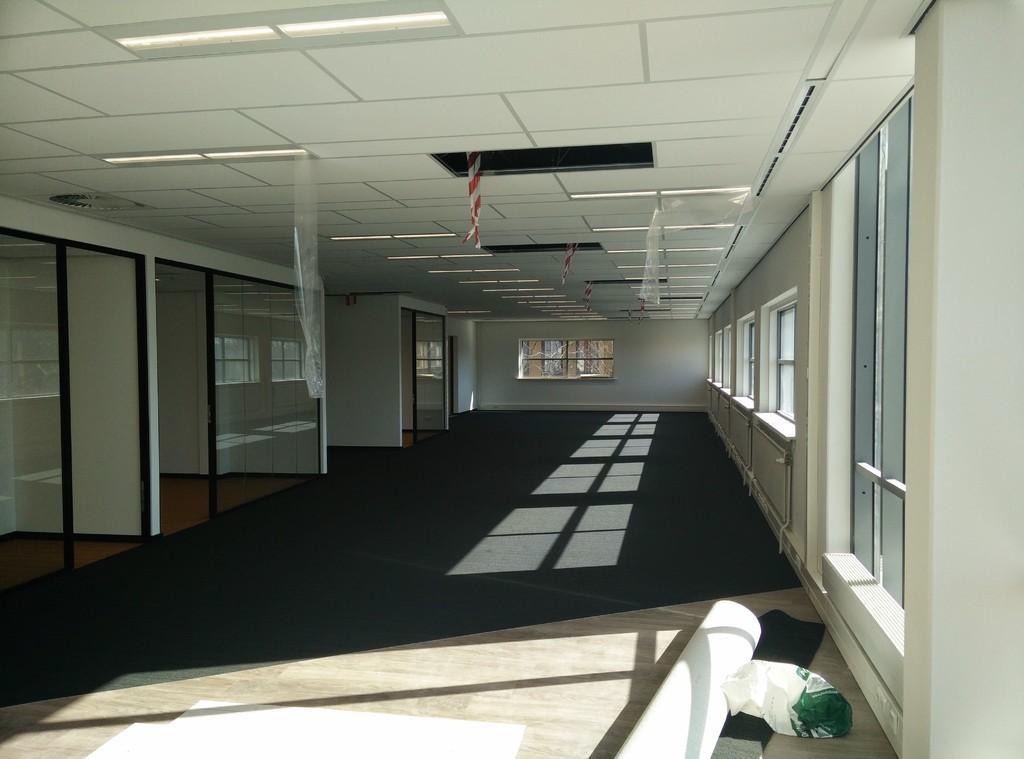Describe this image in one or two sentences. In this image, we can see walls, glass objects and windows. At the bottom, we can see few objects on the floor. Top of the image, we can see the ceiling, lights and covers. 